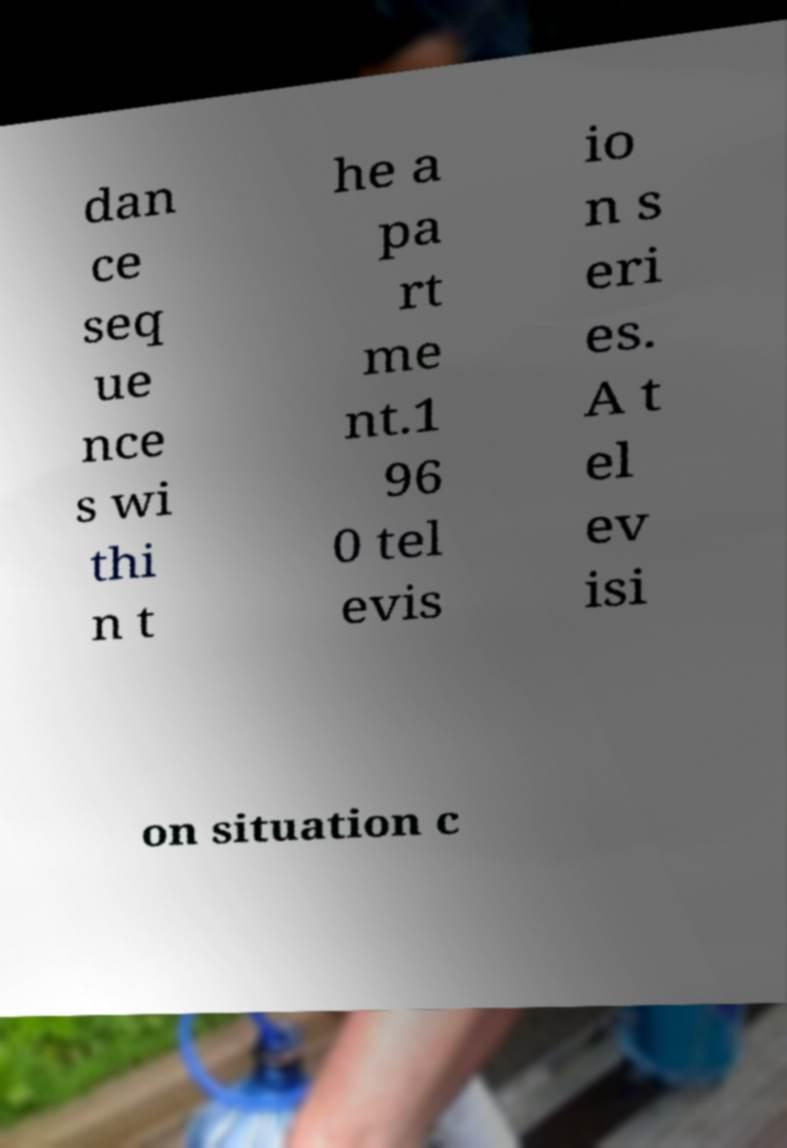Could you assist in decoding the text presented in this image and type it out clearly? dan ce seq ue nce s wi thi n t he a pa rt me nt.1 96 0 tel evis io n s eri es. A t el ev isi on situation c 